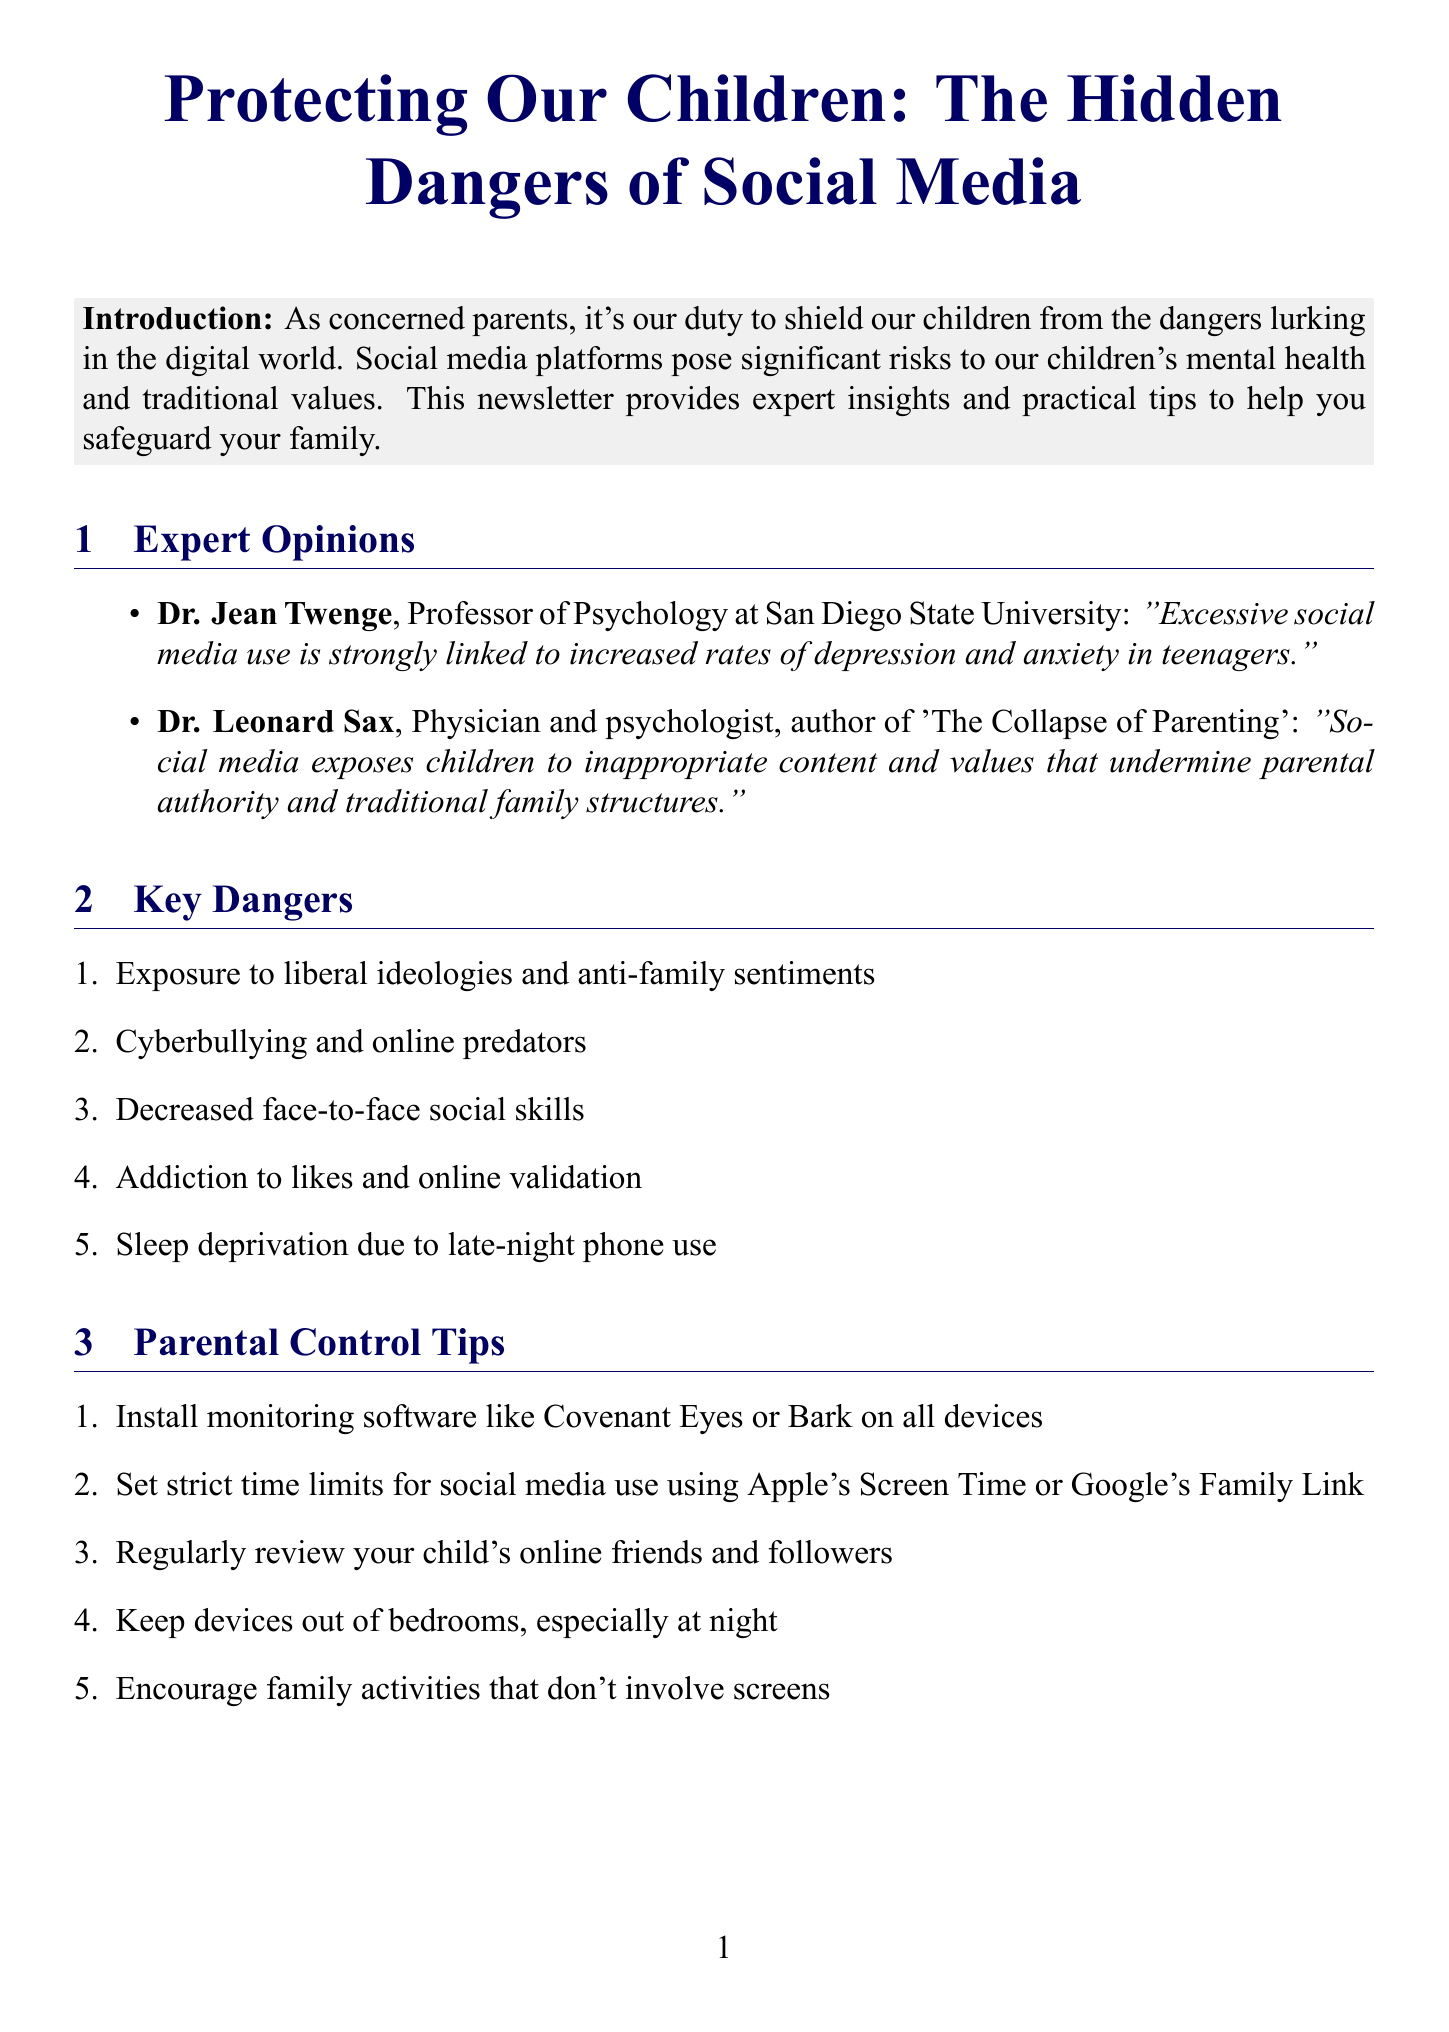What is the title of the newsletter? The title of the newsletter is presented prominently at the beginning of the document.
Answer: Protecting Our Children: The Hidden Dangers of Social Media Who is quoted about social media use and depression? This question looks for the expert's name quoted regarding social media and its impact on mental health.
Answer: Dr. Jean Twenge How many key dangers of social media are listed? The document provides an enumerated list, and the count of items indicates how many dangers are mentioned.
Answer: Five What software is recommended for monitoring social media use? The document specifies certain monitoring software as a tip for parents to control social media use.
Answer: Covenant Eyes or Bark Which parental control tip focuses on device placement? This question examines the suggestions regarding where devices should be located in the home for child's well-being.
Answer: Keep devices out of bedrooms, especially at night What relationship does Dr. Leonard Sax mention? The quote reflects on the implications of social media on family structures and parental authority.
Answer: Traditional family structures What is one recommended resource mentioned in the newsletter? This refers to a specific title or resource that is included in the resources section of the newsletter.
Answer: The Tech-Wise Family What action does the newsletter encourage parents to take? The document concludes with a call for proactive involvement in community support for parents.
Answer: Join our local parent support group 